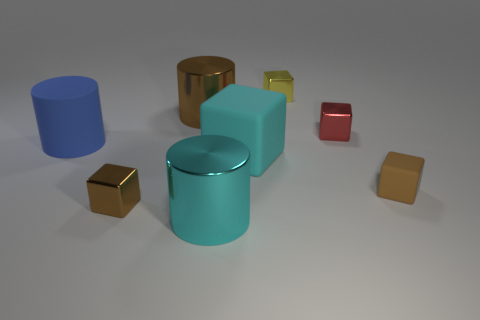Does the large cyan cylinder have the same material as the big cyan cube in front of the big brown thing?
Provide a succinct answer. No. What shape is the big metal thing that is the same color as the large block?
Offer a very short reply. Cylinder. How many red things are the same size as the cyan rubber thing?
Ensure brevity in your answer.  0. Are there fewer tiny yellow shiny objects right of the yellow metal block than big green blocks?
Ensure brevity in your answer.  No. What number of tiny rubber cubes are in front of the brown metallic block?
Offer a very short reply. 0. What size is the cylinder that is on the right side of the metal cylinder that is behind the large thing that is left of the brown cylinder?
Offer a terse response. Large. Is the shape of the small red metal thing the same as the tiny object that is on the left side of the yellow shiny object?
Make the answer very short. Yes. The brown object that is the same material as the blue thing is what size?
Ensure brevity in your answer.  Small. Is there anything else of the same color as the small matte thing?
Offer a terse response. Yes. What material is the tiny brown object to the right of the brown cube on the left side of the brown block that is to the right of the small brown metallic block?
Ensure brevity in your answer.  Rubber. 